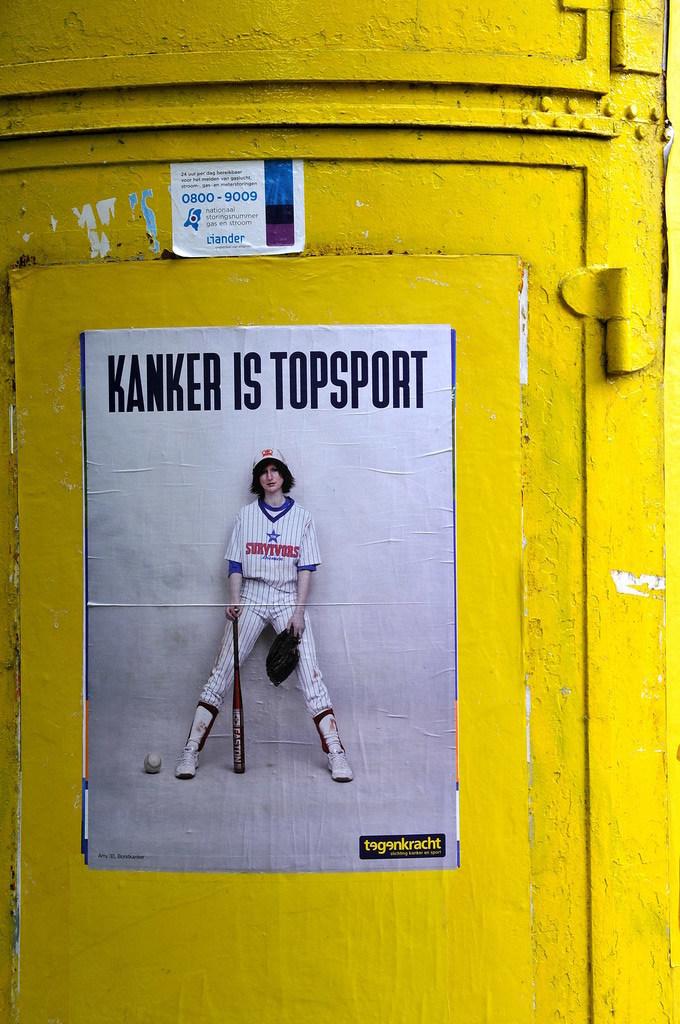What's the phone number on the sticker?
Your answer should be very brief. 0800-9009. 